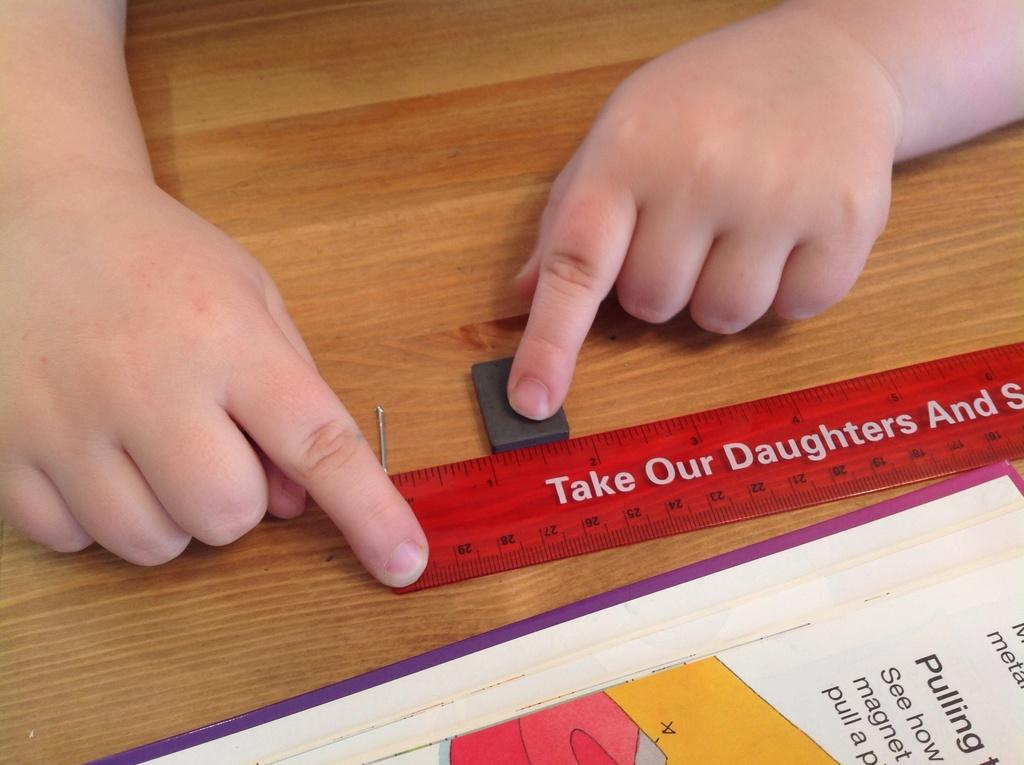<image>
Describe the image concisely. A person lines an object up between the 1 and 2 inch marks of a ruler. 